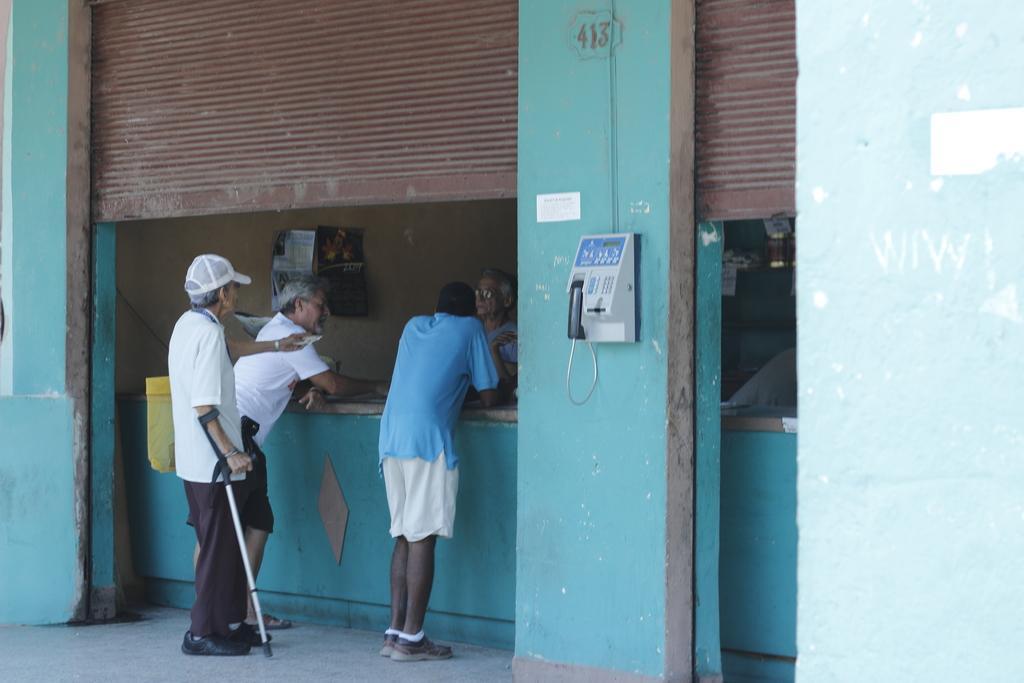Can you describe this image briefly? In this picture we can observe four members standing. All of them were men. One of them was holding a stick in his hand. We can observe brown color shutters and blue color walls. There is a telephone fixed to the blue color wall. 